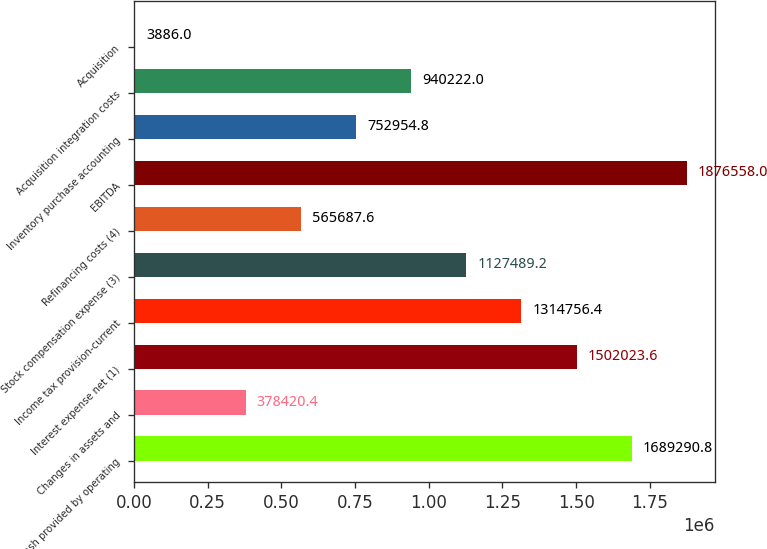Convert chart. <chart><loc_0><loc_0><loc_500><loc_500><bar_chart><fcel>Net cash provided by operating<fcel>Changes in assets and<fcel>Interest expense net (1)<fcel>Income tax provision-current<fcel>Stock compensation expense (3)<fcel>Refinancing costs (4)<fcel>EBITDA<fcel>Inventory purchase accounting<fcel>Acquisition integration costs<fcel>Acquisition<nl><fcel>1.68929e+06<fcel>378420<fcel>1.50202e+06<fcel>1.31476e+06<fcel>1.12749e+06<fcel>565688<fcel>1.87656e+06<fcel>752955<fcel>940222<fcel>3886<nl></chart> 